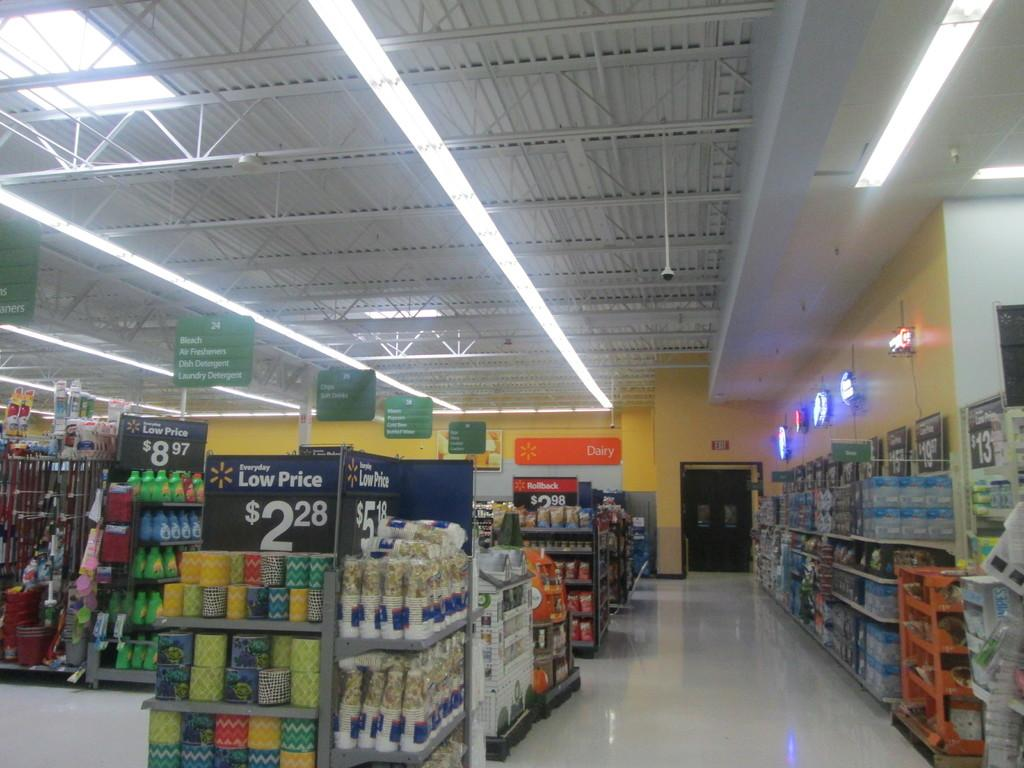<image>
Offer a succinct explanation of the picture presented. Grocery store that says the low price is $2.28 in the front. 